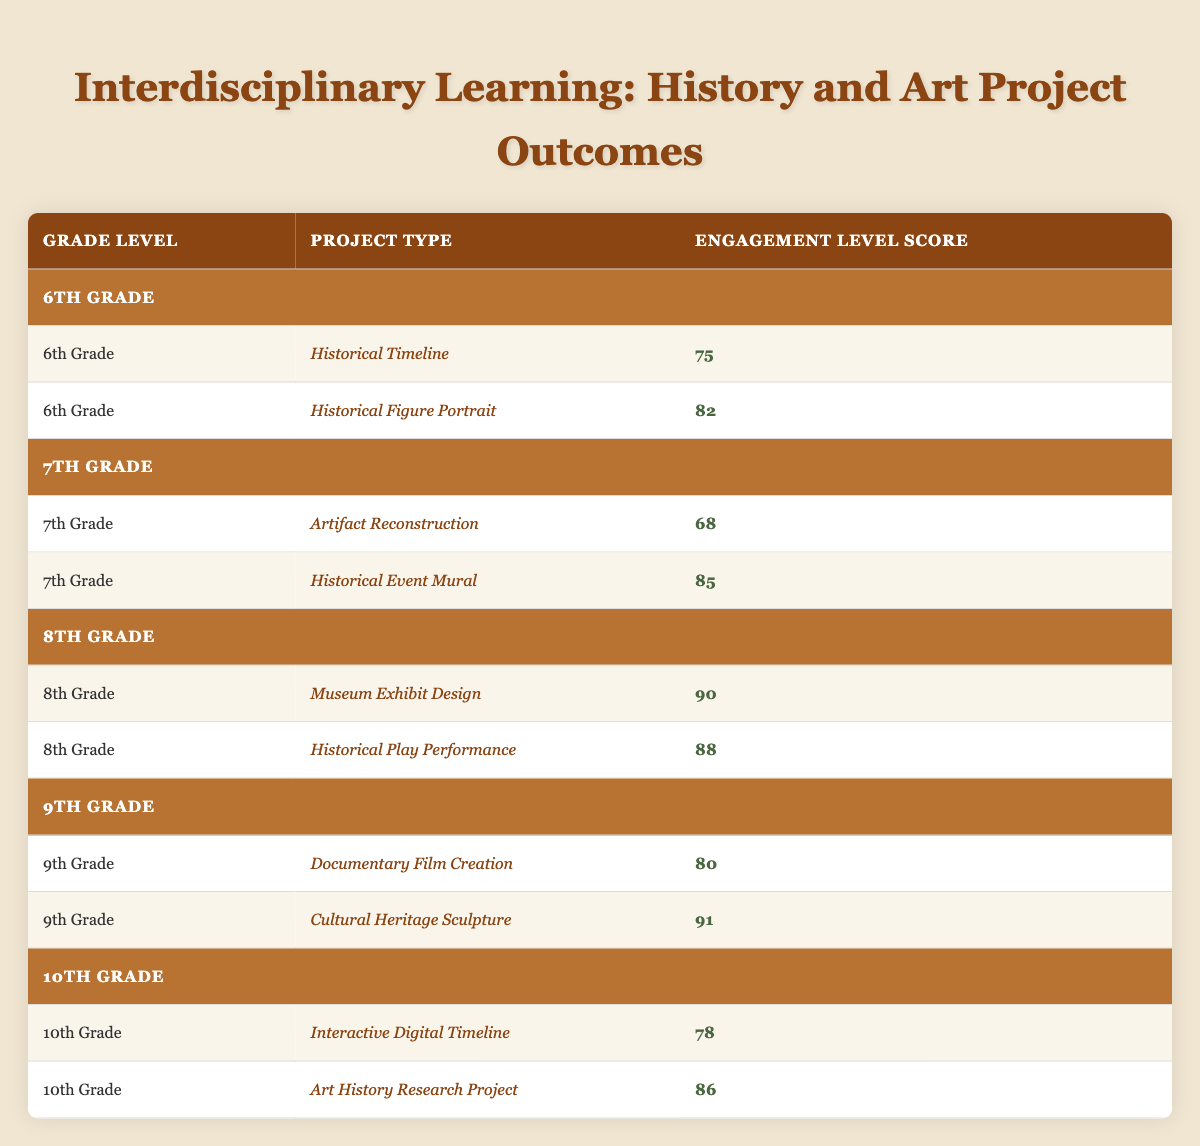What is the engagement level score for the "Historical Figure Portrait" project in 6th Grade? The table indicates the score for the "Historical Figure Portrait" project under the 6th Grade section. The specific score listed there is 82.
Answer: 82 Which project type had the highest engagement level score in 8th Grade? In the 8th Grade section, the scores for the two project types are 90 for "Museum Exhibit Design" and 88 for "Historical Play Performance." Therefore, "Museum Exhibit Design" has the highest score.
Answer: Museum Exhibit Design What is the average engagement level score for all the projects in 9th Grade? The scores for the two projects in 9th Grade are 80 and 91. To find the average, sum these scores: 80 + 91 = 171. Then, divide by the number of projects (2), so 171 / 2 = 85.5.
Answer: 85.5 Is the engagement level score for the "Artifact Reconstruction" project greater than 70? The score for "Artifact Reconstruction" is 68, which is not greater than 70.
Answer: No Which grade level shows the largest difference between the highest and lowest engagement level scores? First, identify the scores per grade level: 6th Grade (75 and 82, difference of 7), 7th Grade (68 and 85, difference of 17), 8th Grade (90 and 88, difference of 2), 9th Grade (80 and 91, difference of 11), and 10th Grade (78 and 86, difference of 8). The largest difference is 17 in the 7th Grade.
Answer: 7th Grade What is the score for the "Interactive Digital Timeline" project in 10th Grade? The score for "Interactive Digital Timeline" is listed under the 10th Grade section, where it clearly shows a score of 78.
Answer: 78 Which project type in 10th Grade had a higher engagement level score, "Interactive Digital Timeline" or "Art History Research Project"? The scores are 78 for "Interactive Digital Timeline" and 86 for "Art History Research Project." Thus, "Art History Research Project" has the higher score.
Answer: Art History Research Project Are there any projects in 7th Grade with scores above 80? In 7th Grade, the scores are 68 for "Artifact Reconstruction" and 85 for "Historical Event Mural." Since 85 is above 80, the answer is yes.
Answer: Yes 